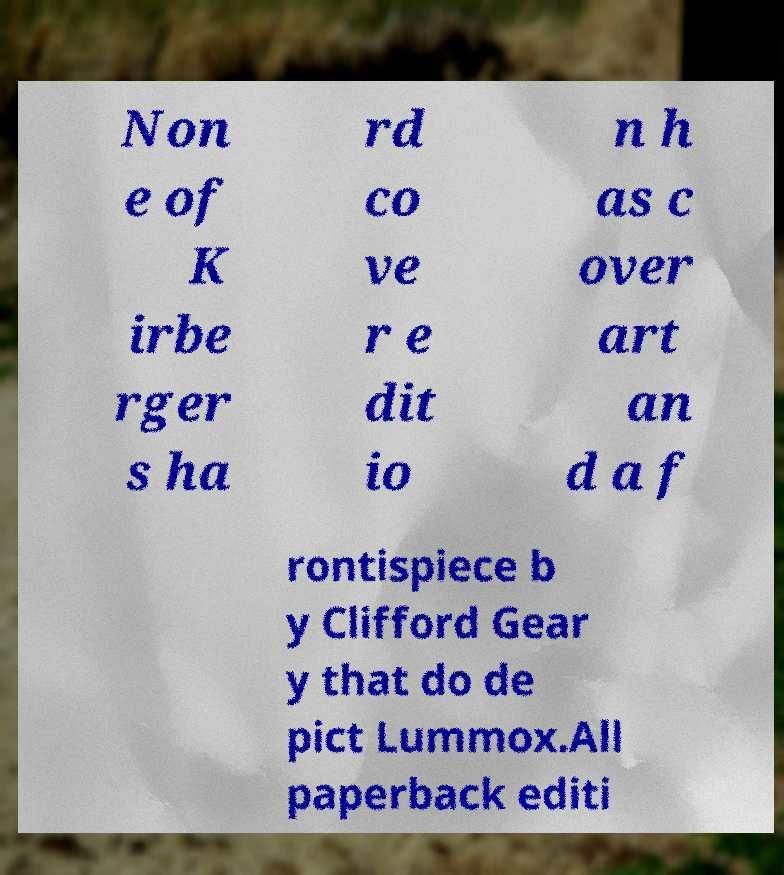For documentation purposes, I need the text within this image transcribed. Could you provide that? Non e of K irbe rger s ha rd co ve r e dit io n h as c over art an d a f rontispiece b y Clifford Gear y that do de pict Lummox.All paperback editi 